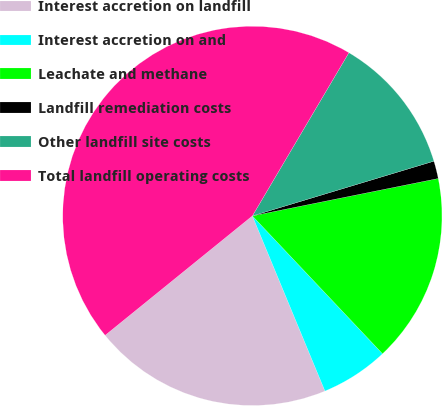<chart> <loc_0><loc_0><loc_500><loc_500><pie_chart><fcel>Interest accretion on landfill<fcel>Interest accretion on and<fcel>Leachate and methane<fcel>Landfill remediation costs<fcel>Other landfill site costs<fcel>Total landfill operating costs<nl><fcel>20.41%<fcel>5.79%<fcel>16.12%<fcel>1.5%<fcel>11.84%<fcel>44.35%<nl></chart> 